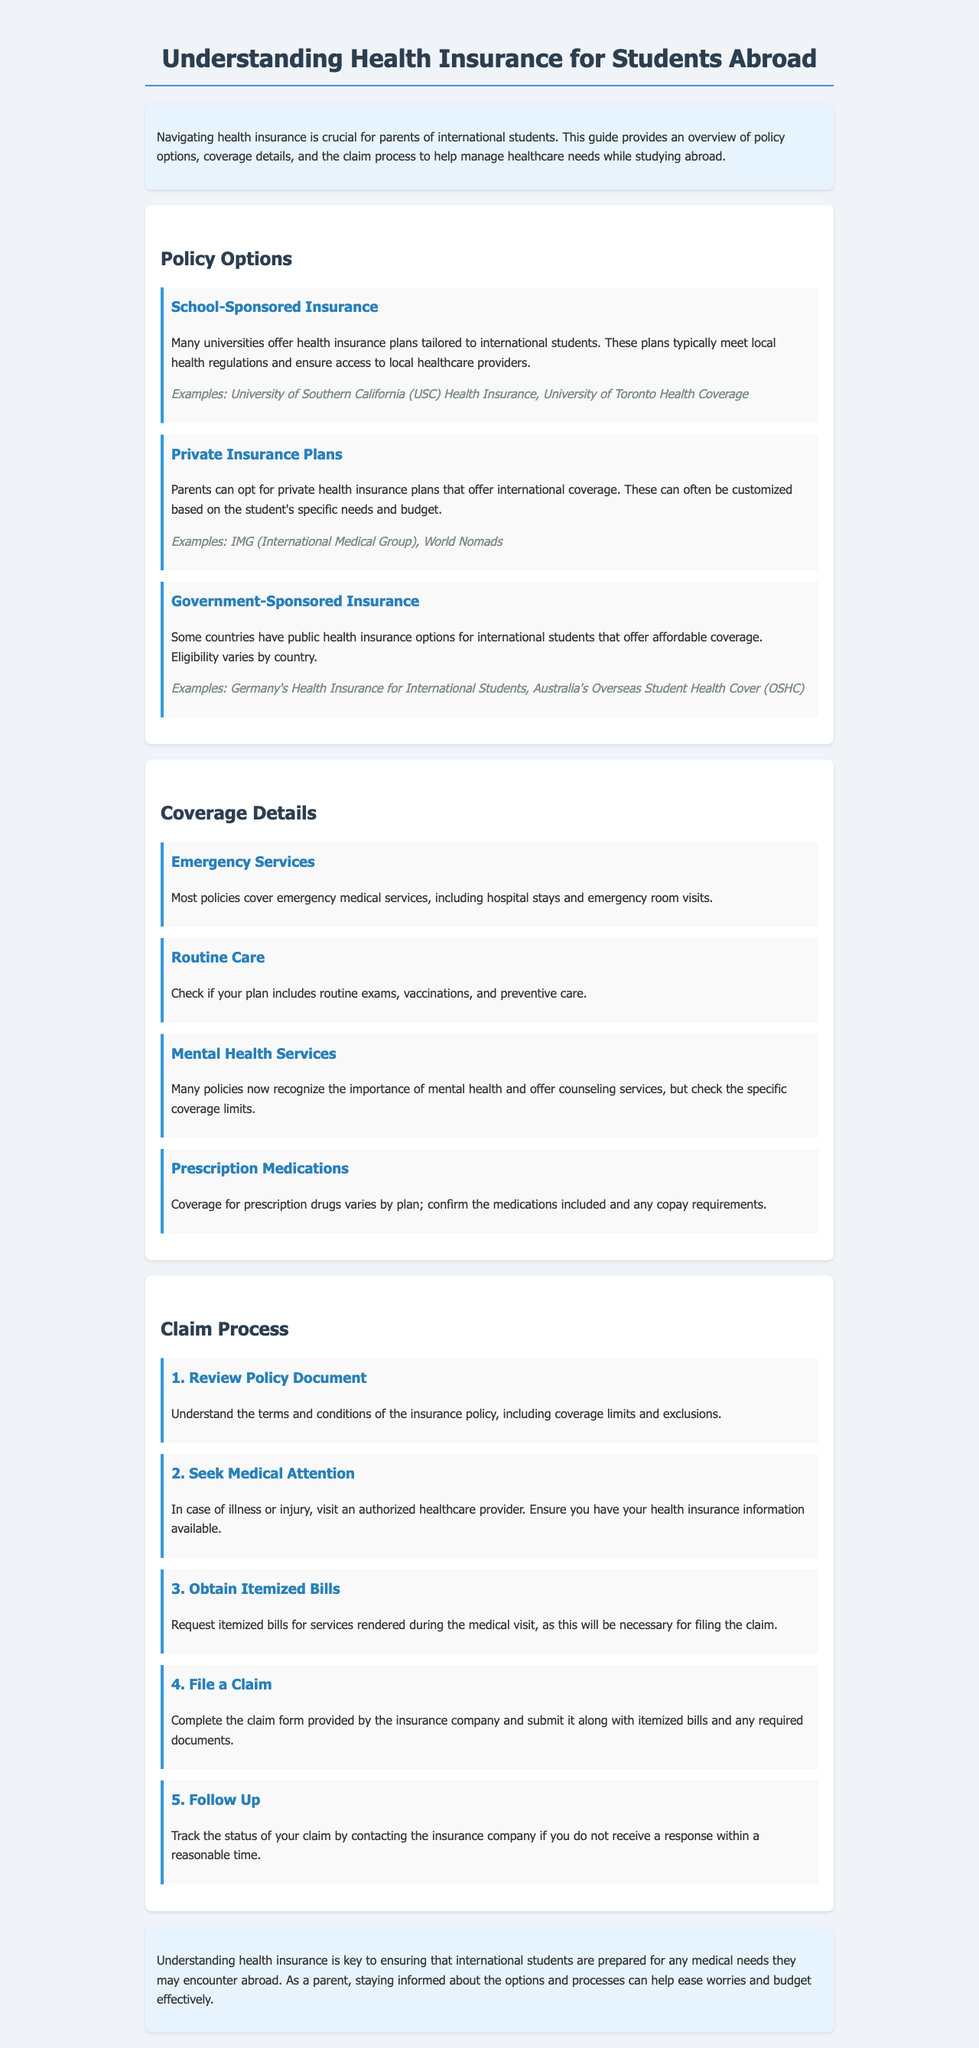What is the title of the document? The title is displayed prominently at the top of the document, stating the subject matter.
Answer: Understanding Health Insurance for Students Abroad What is one example of school-sponsored insurance mentioned? The document includes specific examples of school-sponsored insurance plans in the text.
Answer: University of Southern California (USC) Health Insurance Which coverage item relates to regular check-ups? The section on coverage details discusses various services that are covered, including preventative care.
Answer: Routine Care How many steps are in the claim process? The document outlines the steps involved in filing a claim, which can easily be counted.
Answer: 5 What type of services is recognized in many policies now? The coverage details section mentions this aspect specifically, highlighting evolving coverage areas.
Answer: Mental Health Services What is the first step in the claim process? The document clearly lists the initial action required when filing a claim for insurance.
Answer: Review Policy Document Which option is typically customizable? The document specifies which type of insurance plan can be tailored to individual needs and requirements.
Answer: Private Insurance Plans What should you obtain after seeking medical attention? This is stated explicitly as a necessary action during the claim filing process.
Answer: Itemized Bills 